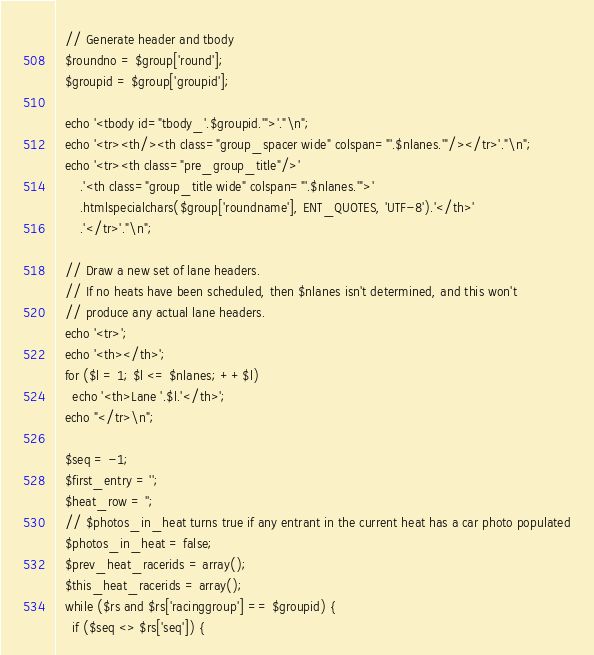<code> <loc_0><loc_0><loc_500><loc_500><_PHP_>  // Generate header and tbody
  $roundno = $group['round'];
  $groupid = $group['groupid'];

  echo '<tbody id="tbody_'.$groupid.'">'."\n";
  echo '<tr><th/><th class="group_spacer wide" colspan="'.$nlanes.'"/></tr>'."\n";
  echo '<tr><th class="pre_group_title"/>'
      .'<th class="group_title wide" colspan="'.$nlanes.'">'
      .htmlspecialchars($group['roundname'], ENT_QUOTES, 'UTF-8').'</th>'
      .'</tr>'."\n";

  // Draw a new set of lane headers.
  // If no heats have been scheduled, then $nlanes isn't determined, and this won't 
  // produce any actual lane headers.
  echo '<tr>';
  echo '<th></th>';
  for ($l = 1; $l <= $nlanes; ++$l)
    echo '<th>Lane '.$l.'</th>';
  echo "</tr>\n";

  $seq = -1;
  $first_entry = '';
  $heat_row = '';
  // $photos_in_heat turns true if any entrant in the current heat has a car photo populated
  $photos_in_heat = false;
  $prev_heat_racerids = array();
  $this_heat_racerids = array();
  while ($rs and $rs['racinggroup'] == $groupid) {
    if ($seq <> $rs['seq']) {</code> 